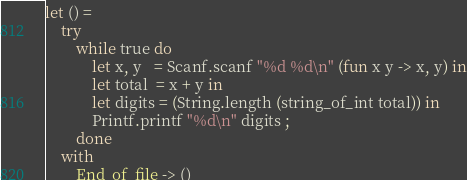Convert code to text. <code><loc_0><loc_0><loc_500><loc_500><_OCaml_>let () =
    try
        while true do
            let x, y   = Scanf.scanf "%d %d\n" (fun x y -> x, y) in
            let total  = x + y in
            let digits = (String.length (string_of_int total)) in
            Printf.printf "%d\n" digits ;
        done
    with
        End_of_file -> ()</code> 